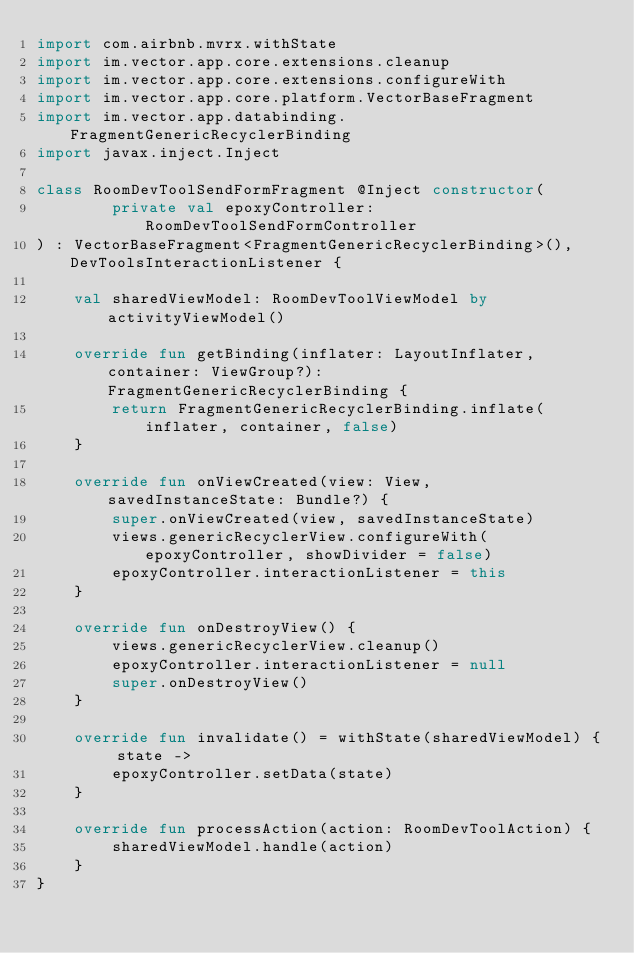Convert code to text. <code><loc_0><loc_0><loc_500><loc_500><_Kotlin_>import com.airbnb.mvrx.withState
import im.vector.app.core.extensions.cleanup
import im.vector.app.core.extensions.configureWith
import im.vector.app.core.platform.VectorBaseFragment
import im.vector.app.databinding.FragmentGenericRecyclerBinding
import javax.inject.Inject

class RoomDevToolSendFormFragment @Inject constructor(
        private val epoxyController: RoomDevToolSendFormController
) : VectorBaseFragment<FragmentGenericRecyclerBinding>(), DevToolsInteractionListener {

    val sharedViewModel: RoomDevToolViewModel by activityViewModel()

    override fun getBinding(inflater: LayoutInflater, container: ViewGroup?): FragmentGenericRecyclerBinding {
        return FragmentGenericRecyclerBinding.inflate(inflater, container, false)
    }

    override fun onViewCreated(view: View, savedInstanceState: Bundle?) {
        super.onViewCreated(view, savedInstanceState)
        views.genericRecyclerView.configureWith(epoxyController, showDivider = false)
        epoxyController.interactionListener = this
    }

    override fun onDestroyView() {
        views.genericRecyclerView.cleanup()
        epoxyController.interactionListener = null
        super.onDestroyView()
    }

    override fun invalidate() = withState(sharedViewModel) { state ->
        epoxyController.setData(state)
    }

    override fun processAction(action: RoomDevToolAction) {
        sharedViewModel.handle(action)
    }
}
</code> 